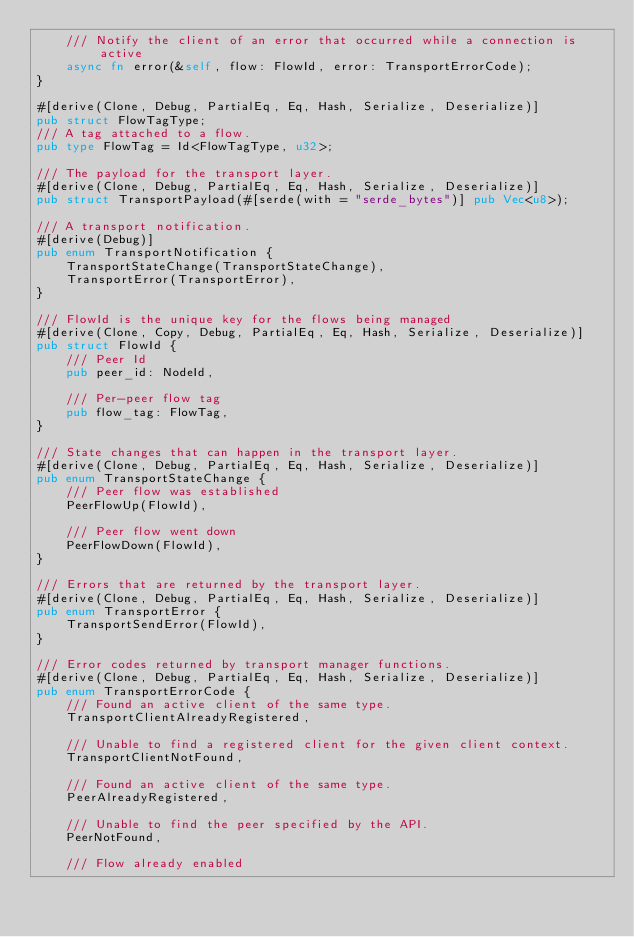<code> <loc_0><loc_0><loc_500><loc_500><_Rust_>    /// Notify the client of an error that occurred while a connection is active
    async fn error(&self, flow: FlowId, error: TransportErrorCode);
}

#[derive(Clone, Debug, PartialEq, Eq, Hash, Serialize, Deserialize)]
pub struct FlowTagType;
/// A tag attached to a flow.
pub type FlowTag = Id<FlowTagType, u32>;

/// The payload for the transport layer.
#[derive(Clone, Debug, PartialEq, Eq, Hash, Serialize, Deserialize)]
pub struct TransportPayload(#[serde(with = "serde_bytes")] pub Vec<u8>);

/// A transport notification.
#[derive(Debug)]
pub enum TransportNotification {
    TransportStateChange(TransportStateChange),
    TransportError(TransportError),
}

/// FlowId is the unique key for the flows being managed
#[derive(Clone, Copy, Debug, PartialEq, Eq, Hash, Serialize, Deserialize)]
pub struct FlowId {
    /// Peer Id
    pub peer_id: NodeId,

    /// Per-peer flow tag
    pub flow_tag: FlowTag,
}

/// State changes that can happen in the transport layer.
#[derive(Clone, Debug, PartialEq, Eq, Hash, Serialize, Deserialize)]
pub enum TransportStateChange {
    /// Peer flow was established
    PeerFlowUp(FlowId),

    /// Peer flow went down
    PeerFlowDown(FlowId),
}

/// Errors that are returned by the transport layer.
#[derive(Clone, Debug, PartialEq, Eq, Hash, Serialize, Deserialize)]
pub enum TransportError {
    TransportSendError(FlowId),
}

/// Error codes returned by transport manager functions.
#[derive(Clone, Debug, PartialEq, Eq, Hash, Serialize, Deserialize)]
pub enum TransportErrorCode {
    /// Found an active client of the same type.
    TransportClientAlreadyRegistered,

    /// Unable to find a registered client for the given client context.
    TransportClientNotFound,

    /// Found an active client of the same type.
    PeerAlreadyRegistered,

    /// Unable to find the peer specified by the API.
    PeerNotFound,

    /// Flow already enabled</code> 